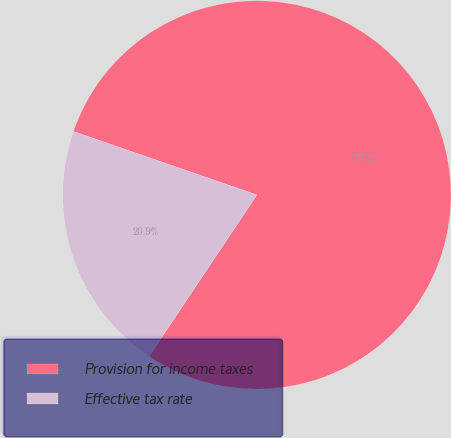Convert chart to OTSL. <chart><loc_0><loc_0><loc_500><loc_500><pie_chart><fcel>Provision for income taxes<fcel>Effective tax rate<nl><fcel>79.07%<fcel>20.93%<nl></chart> 